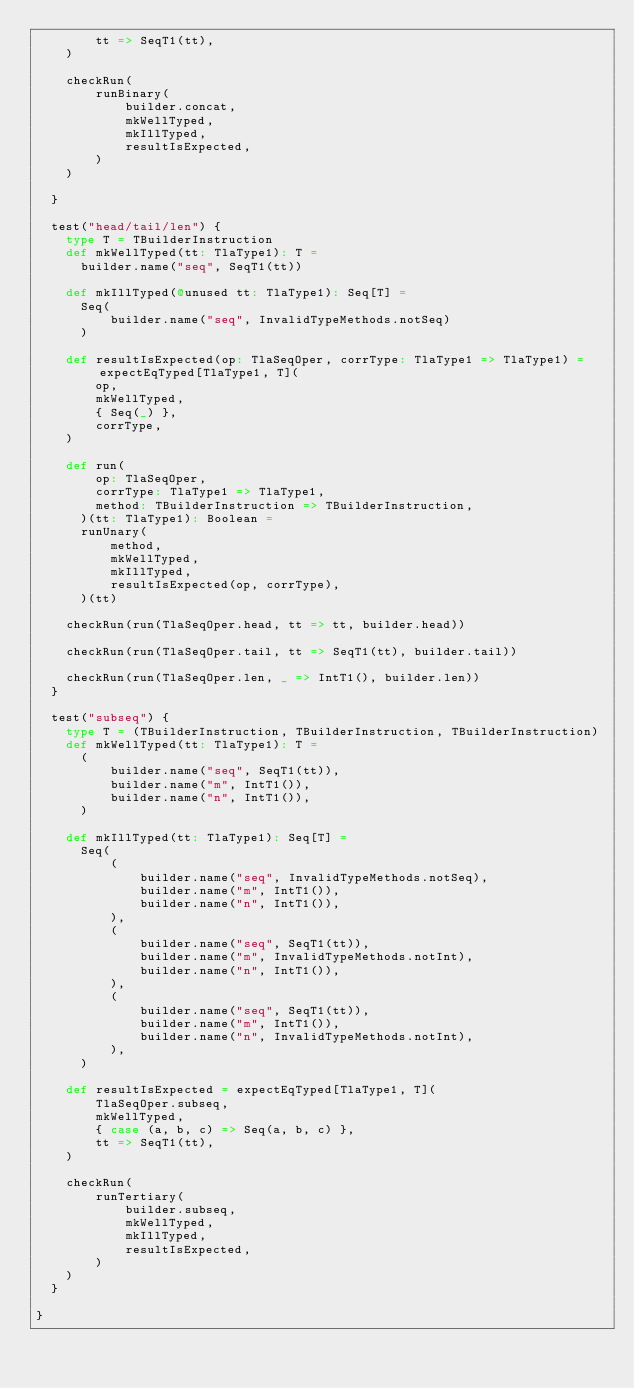<code> <loc_0><loc_0><loc_500><loc_500><_Scala_>        tt => SeqT1(tt),
    )

    checkRun(
        runBinary(
            builder.concat,
            mkWellTyped,
            mkIllTyped,
            resultIsExpected,
        )
    )

  }

  test("head/tail/len") {
    type T = TBuilderInstruction
    def mkWellTyped(tt: TlaType1): T =
      builder.name("seq", SeqT1(tt))

    def mkIllTyped(@unused tt: TlaType1): Seq[T] =
      Seq(
          builder.name("seq", InvalidTypeMethods.notSeq)
      )

    def resultIsExpected(op: TlaSeqOper, corrType: TlaType1 => TlaType1) = expectEqTyped[TlaType1, T](
        op,
        mkWellTyped,
        { Seq(_) },
        corrType,
    )

    def run(
        op: TlaSeqOper,
        corrType: TlaType1 => TlaType1,
        method: TBuilderInstruction => TBuilderInstruction,
      )(tt: TlaType1): Boolean =
      runUnary(
          method,
          mkWellTyped,
          mkIllTyped,
          resultIsExpected(op, corrType),
      )(tt)

    checkRun(run(TlaSeqOper.head, tt => tt, builder.head))

    checkRun(run(TlaSeqOper.tail, tt => SeqT1(tt), builder.tail))

    checkRun(run(TlaSeqOper.len, _ => IntT1(), builder.len))
  }

  test("subseq") {
    type T = (TBuilderInstruction, TBuilderInstruction, TBuilderInstruction)
    def mkWellTyped(tt: TlaType1): T =
      (
          builder.name("seq", SeqT1(tt)),
          builder.name("m", IntT1()),
          builder.name("n", IntT1()),
      )

    def mkIllTyped(tt: TlaType1): Seq[T] =
      Seq(
          (
              builder.name("seq", InvalidTypeMethods.notSeq),
              builder.name("m", IntT1()),
              builder.name("n", IntT1()),
          ),
          (
              builder.name("seq", SeqT1(tt)),
              builder.name("m", InvalidTypeMethods.notInt),
              builder.name("n", IntT1()),
          ),
          (
              builder.name("seq", SeqT1(tt)),
              builder.name("m", IntT1()),
              builder.name("n", InvalidTypeMethods.notInt),
          ),
      )

    def resultIsExpected = expectEqTyped[TlaType1, T](
        TlaSeqOper.subseq,
        mkWellTyped,
        { case (a, b, c) => Seq(a, b, c) },
        tt => SeqT1(tt),
    )

    checkRun(
        runTertiary(
            builder.subseq,
            mkWellTyped,
            mkIllTyped,
            resultIsExpected,
        )
    )
  }

}
</code> 